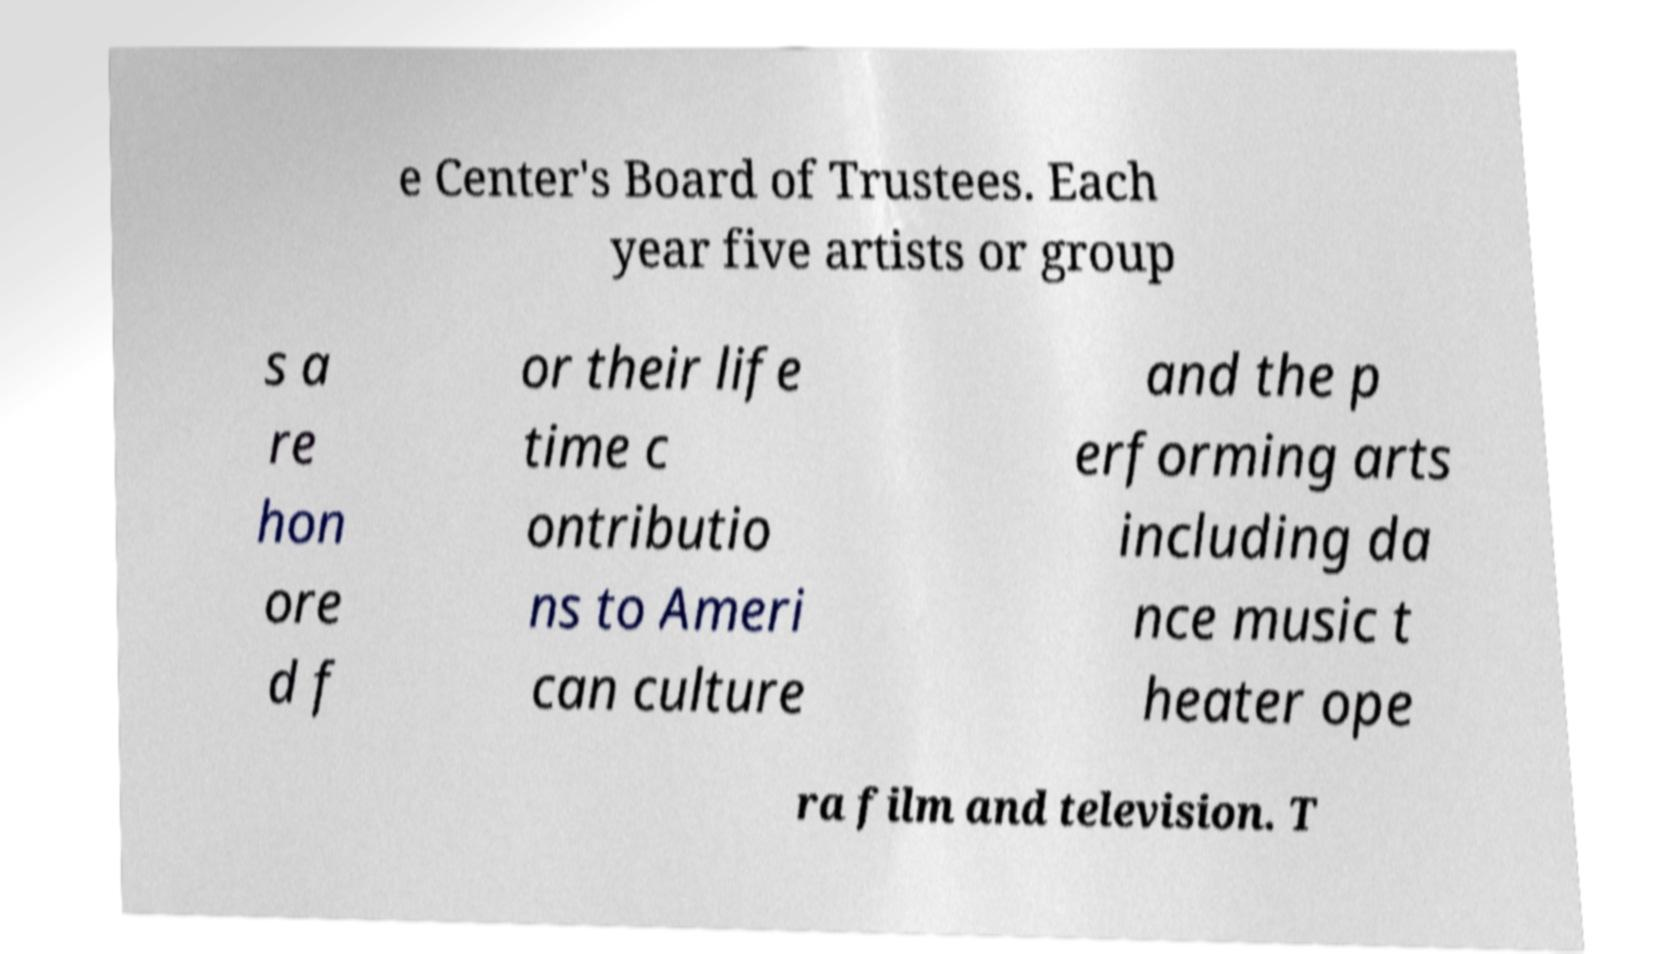Can you accurately transcribe the text from the provided image for me? e Center's Board of Trustees. Each year five artists or group s a re hon ore d f or their life time c ontributio ns to Ameri can culture and the p erforming arts including da nce music t heater ope ra film and television. T 